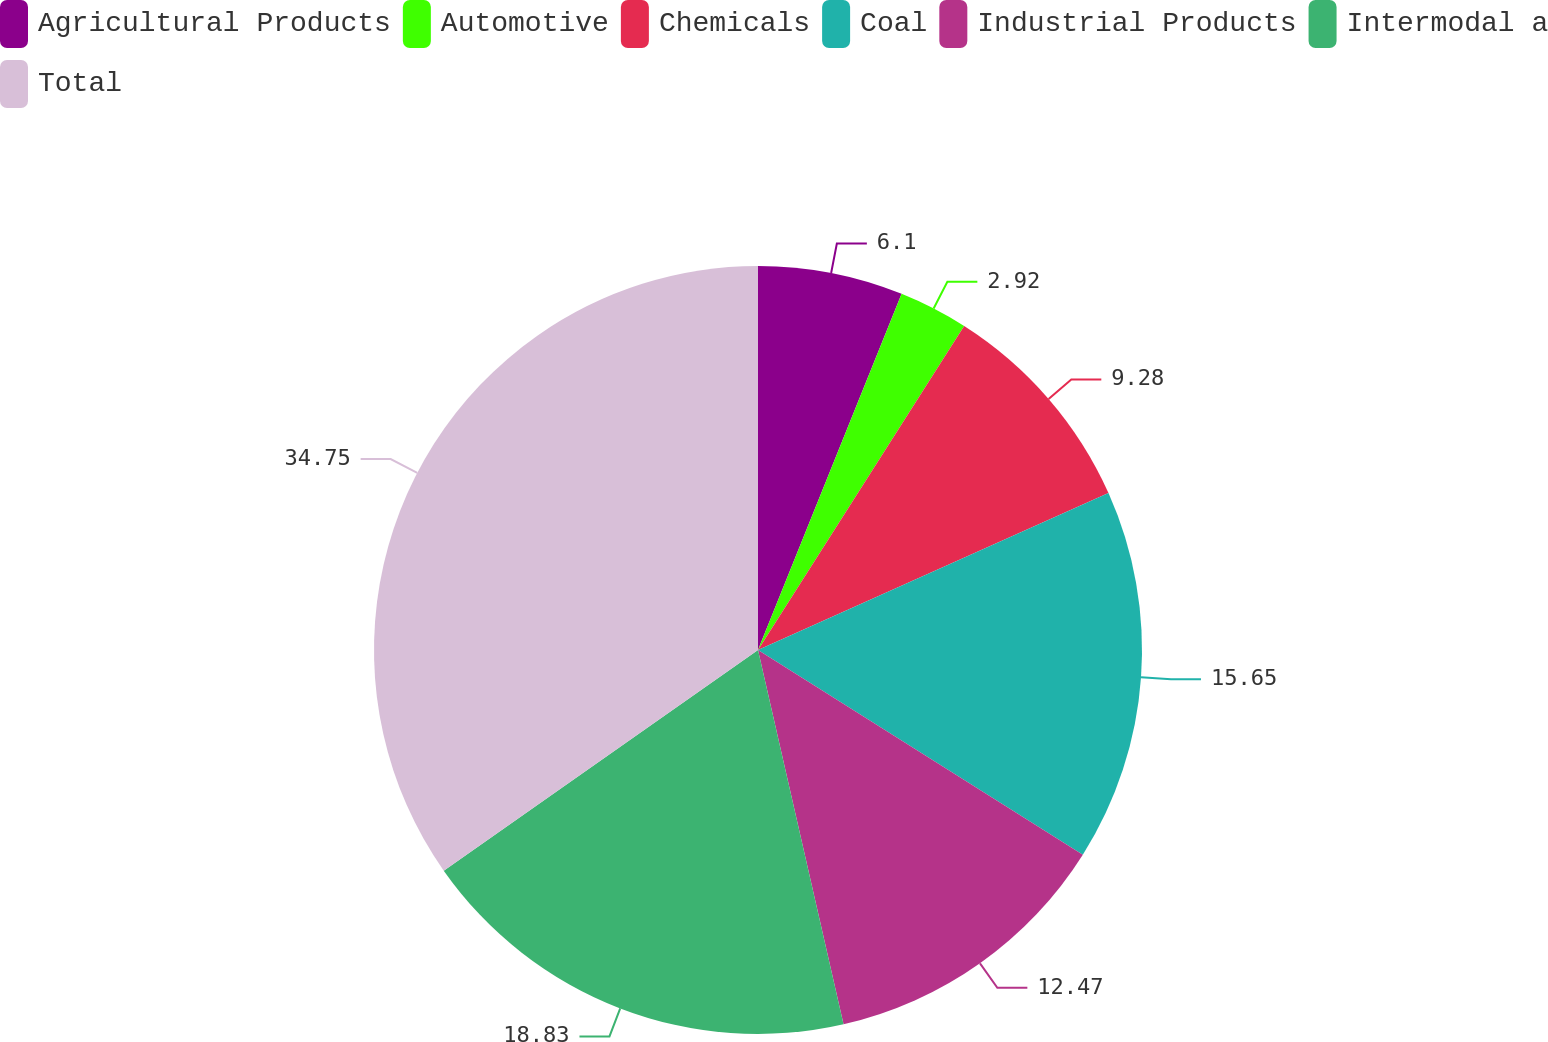<chart> <loc_0><loc_0><loc_500><loc_500><pie_chart><fcel>Agricultural Products<fcel>Automotive<fcel>Chemicals<fcel>Coal<fcel>Industrial Products<fcel>Intermodal a<fcel>Total<nl><fcel>6.1%<fcel>2.92%<fcel>9.28%<fcel>15.65%<fcel>12.47%<fcel>18.83%<fcel>34.74%<nl></chart> 